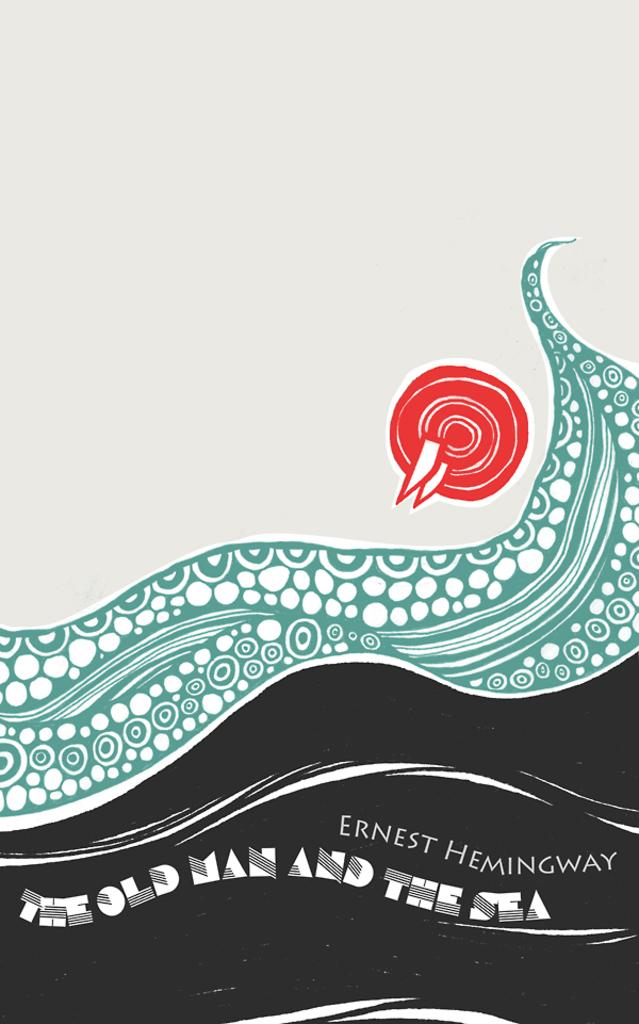<image>
Render a clear and concise summary of the photo. A book cover of The Old Man and the Sea by Ernest Hemingway. 